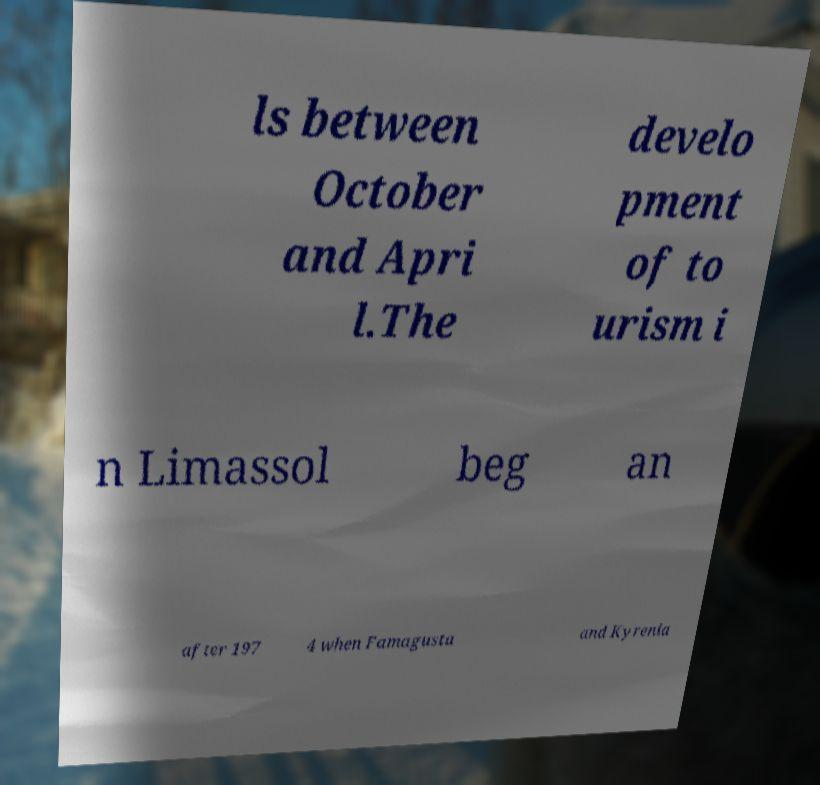I need the written content from this picture converted into text. Can you do that? ls between October and Apri l.The develo pment of to urism i n Limassol beg an after 197 4 when Famagusta and Kyrenia 